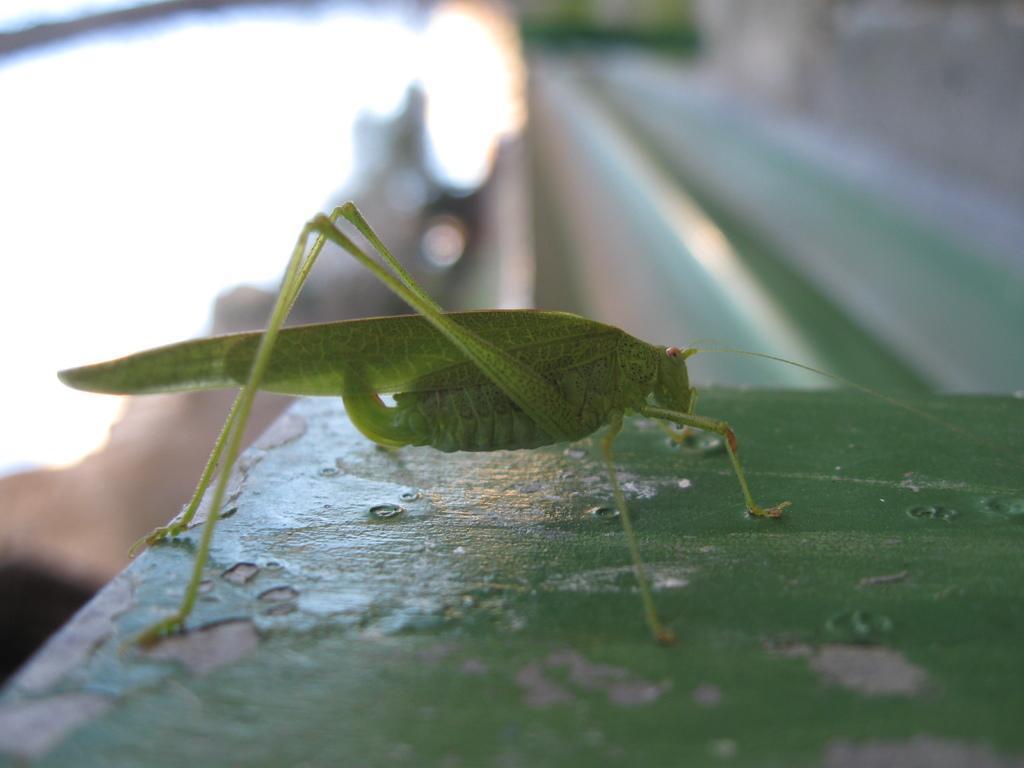In one or two sentences, can you explain what this image depicts? In this picture we can see a grasshopper here, we can see a blurry background. 